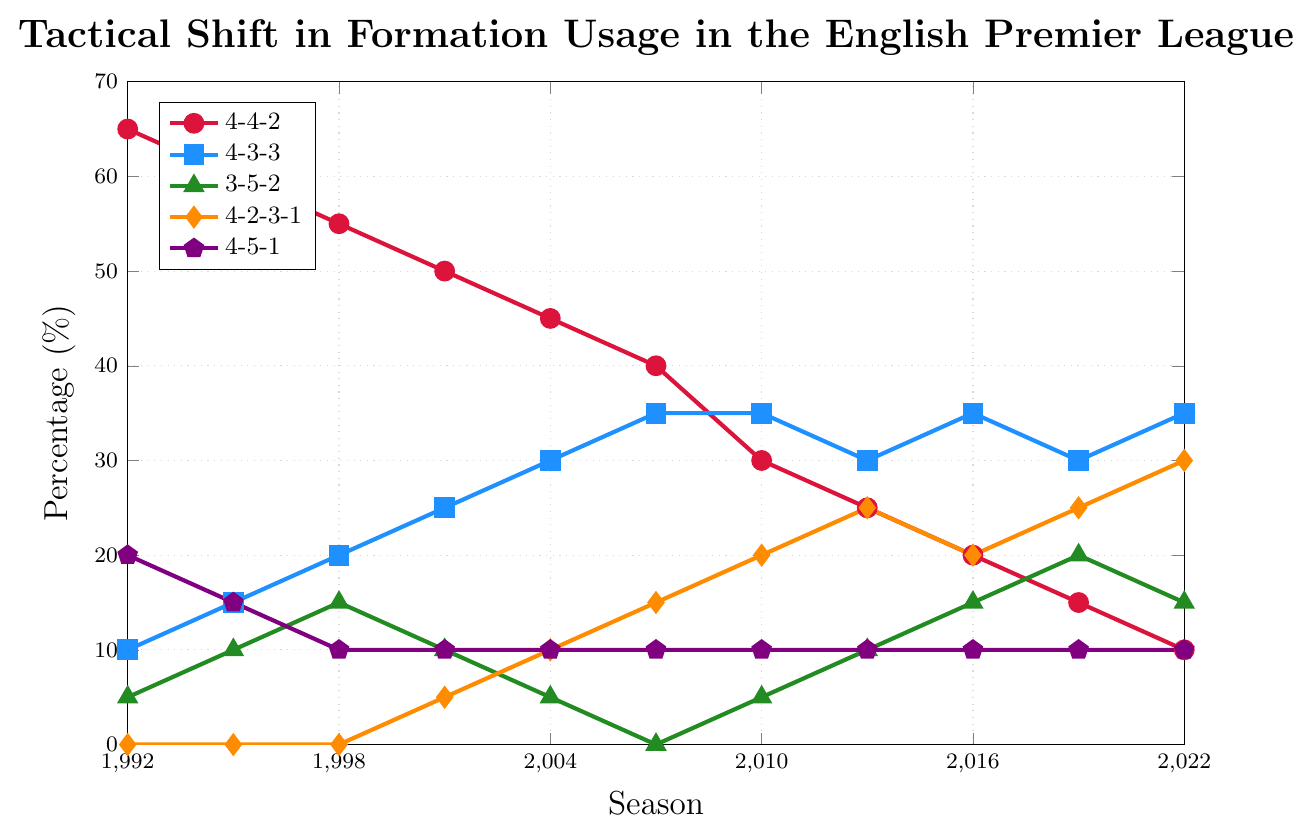Which formation saw the most significant decrease in usage from 1992 to 2022? The usage of the 4-4-2 formation decreased from 65% in 1992 to 10% in 2022, amounting to a 55% decrease, which is the largest decrease among all formations.
Answer: 4-4-2 How did the usage of the 4-3-3 formation change over the 30 years? The usage of the 4-3-3 formation increased from 10% in 1992 to 35% in 2022. It remained stable at some points but overall showed a clear rising trend.
Answer: Increased In which season did the 4-2-3-1 formation start being used? The 4-2-3-1 formation started being used in the 2001-02 season, where its usage was at 5%.
Answer: 2001-02 What formation was the most consistently used over the 30 years, and what was its usage percentage in 2022? The 4-5-1 formation was the most consistently used, maintaining around 10% for most of the period, including in 2022.
Answer: 4-5-1, 10% Which formations had an increase in usage in the 2019-2022 period? Both the 4-3-3 and 4-2-3-1 formations saw an increase in usage from 2019 to 2022. 4-3-3 went from 30% to 35%, and 4-2-3-1 went from 25% to 30%.
Answer: 4-3-3 and 4-2-3-1 What was the combined percentage usage of the 4-4-2 and 3-5-2 formations in 2010? In 2010, the 4-4-2 formation had a usage of 30% and the 3-5-2 formation had a usage of 5%. The combined usage is 30% + 5% = 35%.
Answer: 35% Which formation had its highest usage in 2007-08 and what was the percentage? The 4-3-3 formation reached its highest usage percentage in the 2007-08 season, at 35%.
Answer: 4-3-3, 35% How did the 4-5-1 formation's usage compare to the 4-2-3-1 formation's usage in 2016? In 2016, the 4-5-1 formation had a constant usage of 10%, while the 4-2-3-1 formation had 20%, meaning 4-2-3-1 was twice as used as the 4-5-1 formation.
Answer: 4-5-1 had 10%, 4-2-3-1 had 20% What is the most prominent trend observed in the usage of traditional formations (4-4-2 and 4-3-3) over the years? The 4-4-2 formation shows a significant decreasing trend, while the 4-3-3 formation shows an increasing trend, from 1992 to 2022.
Answer: Decrease in 4-4-2, increase in 4-3-3 